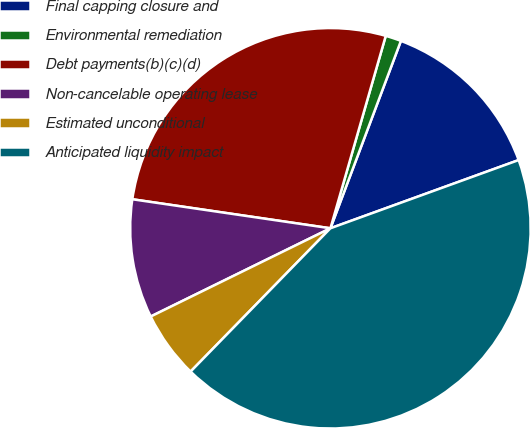Convert chart. <chart><loc_0><loc_0><loc_500><loc_500><pie_chart><fcel>Final capping closure and<fcel>Environmental remediation<fcel>Debt payments(b)(c)(d)<fcel>Non-cancelable operating lease<fcel>Estimated unconditional<fcel>Anticipated liquidity impact<nl><fcel>13.74%<fcel>1.27%<fcel>27.14%<fcel>9.58%<fcel>5.43%<fcel>42.84%<nl></chart> 